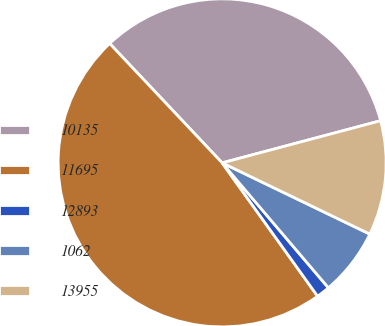Convert chart to OTSL. <chart><loc_0><loc_0><loc_500><loc_500><pie_chart><fcel>10135<fcel>11695<fcel>12893<fcel>1062<fcel>13955<nl><fcel>32.89%<fcel>47.86%<fcel>1.33%<fcel>6.63%<fcel>11.29%<nl></chart> 